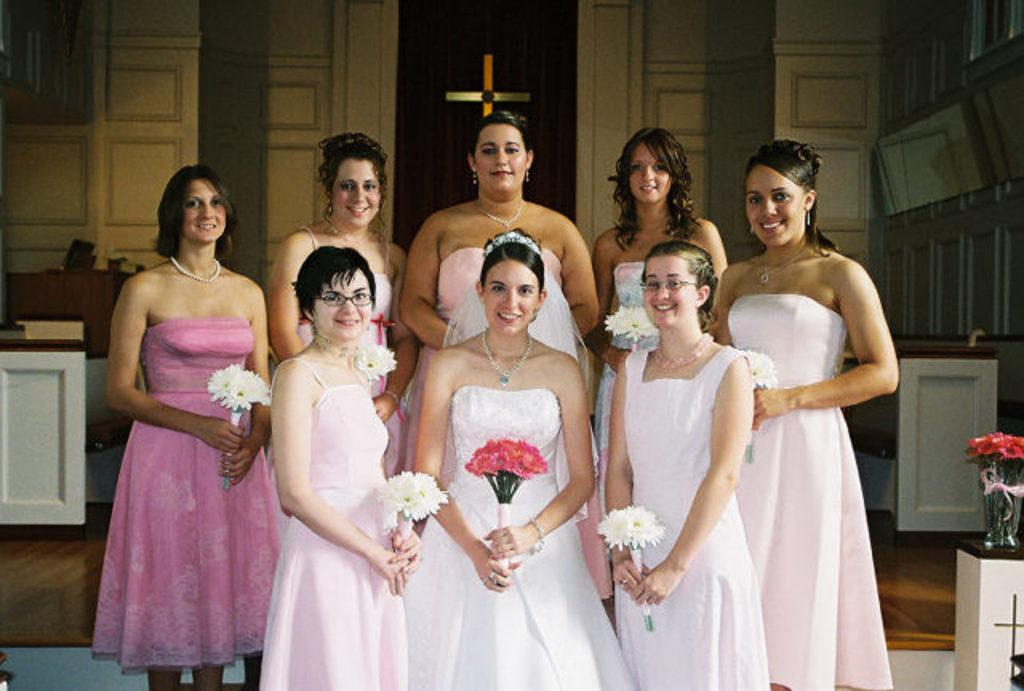What is the primary action being performed by the women in the image? The women in the image are standing and smiling. What are the women holding in the image? The women are holding flowers. What can be seen in the background of the image? There are tables and a wall in the background of the image. What type of hydrant is visible in the image? There is no hydrant present in the image. How many cakes are being served by the women in the image? The women are not serving cakes in the image; they are holding flowers. 